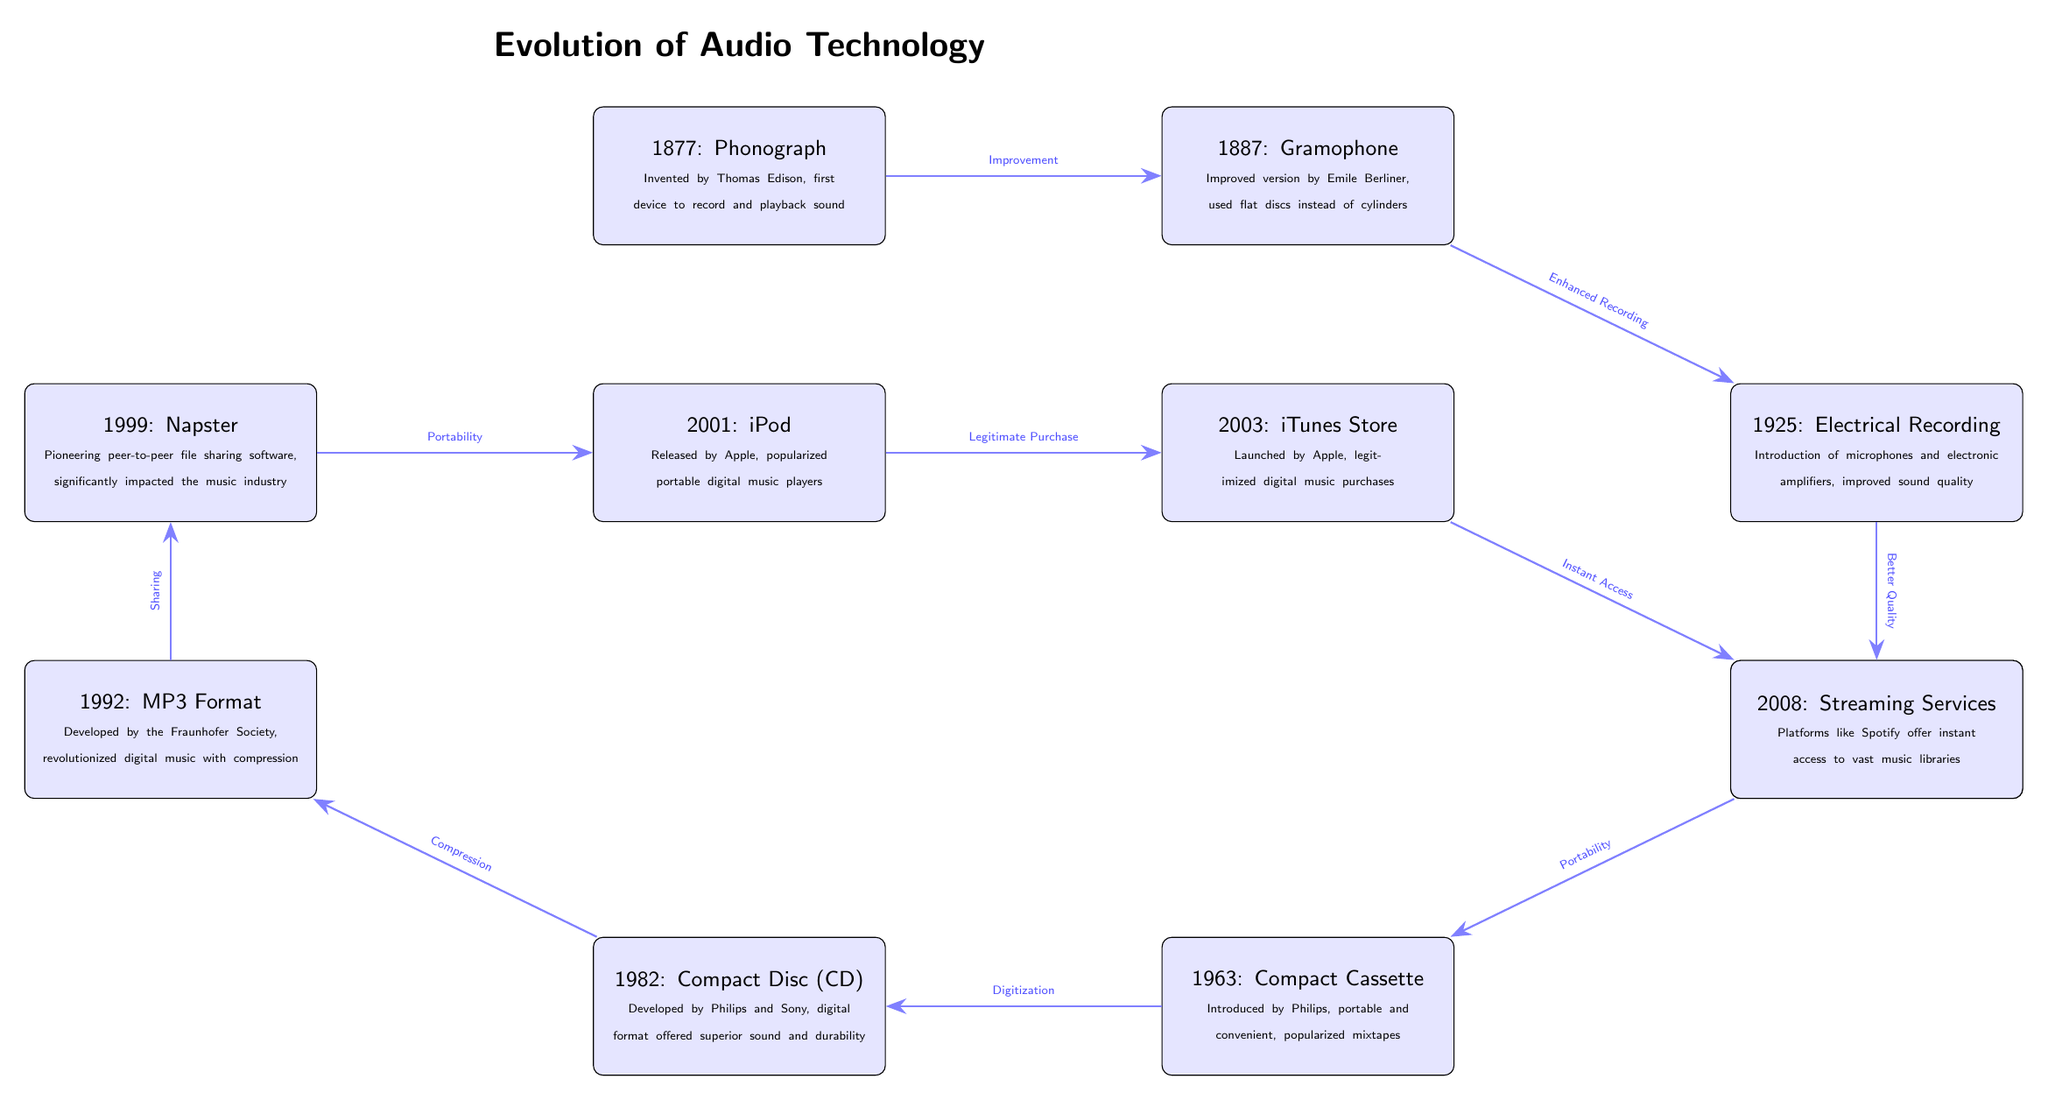What year was the phonograph invented? The phonograph was the first event in the diagram, labeled clearly as "1877: Phonograph". The year mentioned next to the phonograph is 1877.
Answer: 1877 What technological improvement is associated with 1925? The node for 1925 states "Electrical Recording", which indicates that the improvement made at this point in time was the introduction of microphones and electronic amplifiers. The connection from 1925 leads to the note explaining improved sound quality.
Answer: Electrical Recording How many events are depicted in the timeline? By counting the individual nodes in the diagram, we find that there are eleven events connected through arrows, representing the evolution of audio technology.
Answer: 11 What is the relationship between the compact cassette and LP records? The diagram indicates that the relationship is labeled "Portability". The arrow goes from LP records in 1948 to the Compact Cassette in 1963, demonstrating that the development of LP records contributed to the portability features of cassette tapes.
Answer: Portability Which event directly follows the development of the MP3 format? The MP3 format, developed in 1992, is connected by an arrow to the next node, which indicates that Napster, introduced in 1999, directly follows it. The arrow signifies that the development of MP3 impacted the next event in the timeline.
Answer: Napster How did the introduction of the iTunes Store in 2003 change music purchasing? The iTunes Store is noted as having "Legitimized digital music purchases", which describes its significant impact on how music was bought. The arrow reflects that it followed the release of the iPod and connects directly to the node below it about streaming services, showing a clear enhancement in how people accessed music.
Answer: Legitimized digital music purchases What important feature did compact discs (CDs) offer compared to previous formats? The compact discs introduced in 1982 are labeled as a "digital format offered superior sound and durability". This highlights their key improvement over earlier formats like tapes and records, showing advancements in quality and longevity.
Answer: Superior sound and durability Which two developments are directly linked by the concept of "Compression"? The diagram shows that the Compact Disc (1982) leads to the development of the MP3 format in 1992, with "Compression" indicated as the transition. This signifies how moving to a digital format allowed for significant changes in audio file sizes.
Answer: Compact Disc and MP3 Format What type of technology is associated with the year 2008? The diagram lists "Streaming Services" for the year 2008, indicating the introduction of platforms like Spotify that changed how listeners accessed music. This is noted at the end of the timeline, pointing to the latest evolution in music consumption.
Answer: Streaming Services 